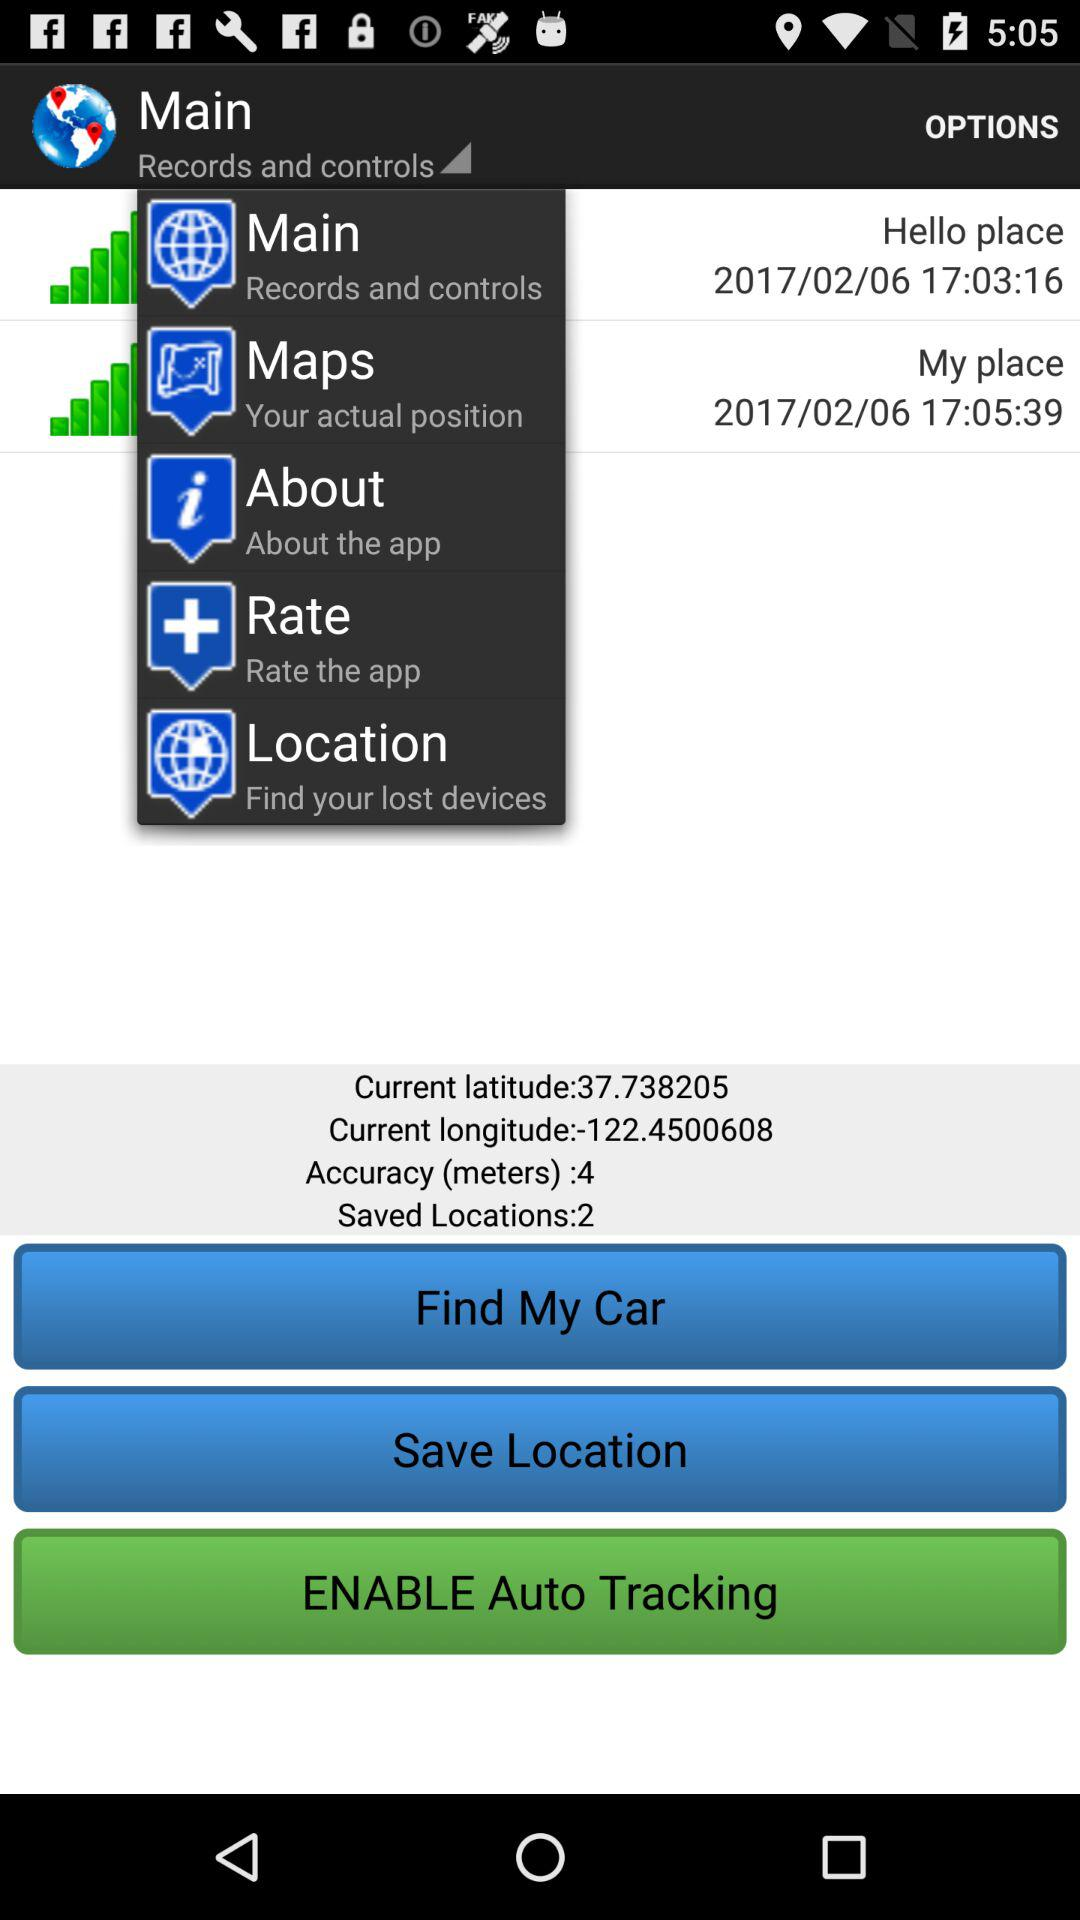What is the date and time of "Hello place"? The date and time are 2017/02/06 and 17:03:16. 